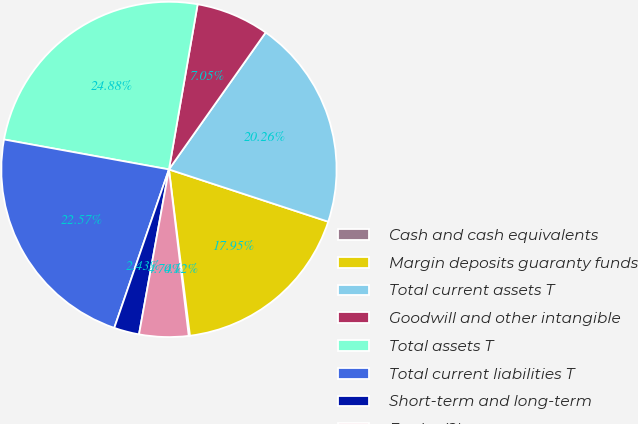Convert chart. <chart><loc_0><loc_0><loc_500><loc_500><pie_chart><fcel>Cash and cash equivalents<fcel>Margin deposits guaranty funds<fcel>Total current assets T<fcel>Goodwill and other intangible<fcel>Total assets T<fcel>Total current liabilities T<fcel>Short-term and long-term<fcel>Equity (2)<nl><fcel>0.12%<fcel>17.95%<fcel>20.26%<fcel>7.05%<fcel>24.88%<fcel>22.57%<fcel>2.43%<fcel>4.74%<nl></chart> 